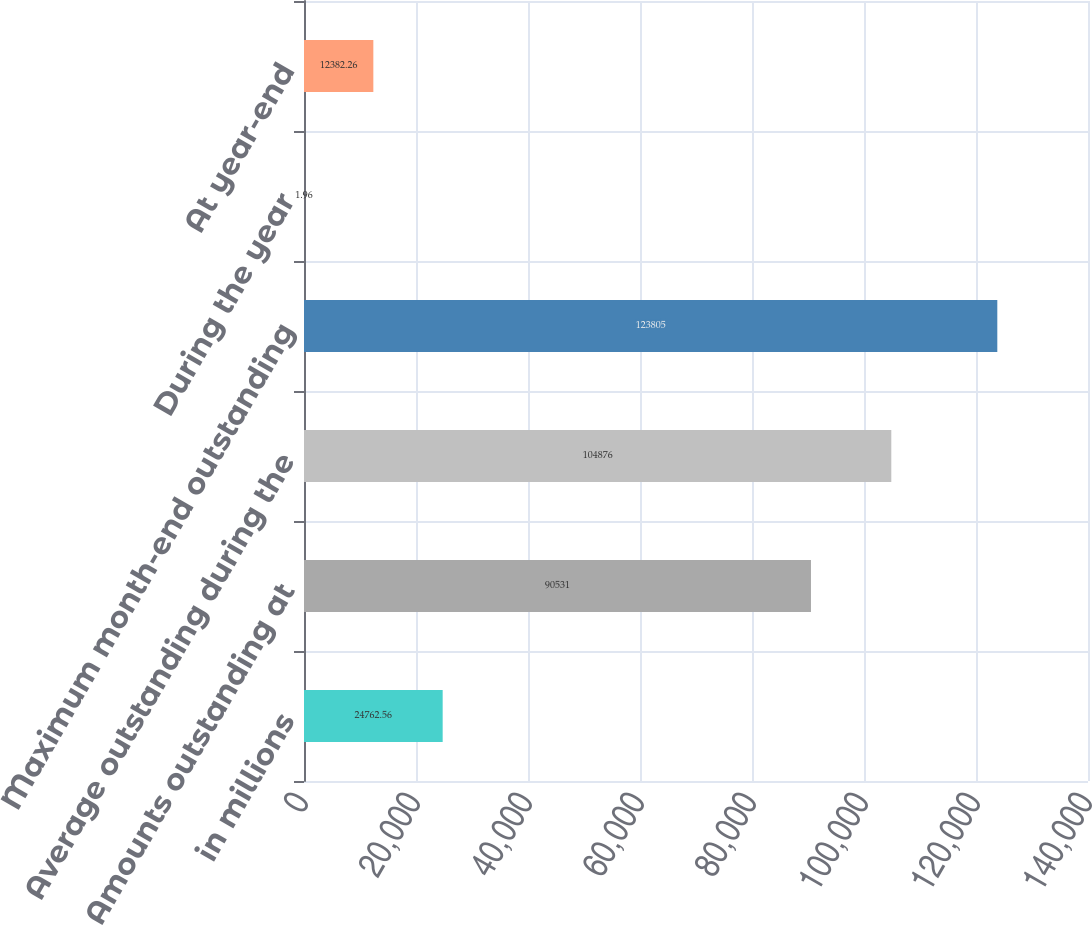<chart> <loc_0><loc_0><loc_500><loc_500><bar_chart><fcel>in millions<fcel>Amounts outstanding at<fcel>Average outstanding during the<fcel>Maximum month-end outstanding<fcel>During the year<fcel>At year-end<nl><fcel>24762.6<fcel>90531<fcel>104876<fcel>123805<fcel>1.96<fcel>12382.3<nl></chart> 